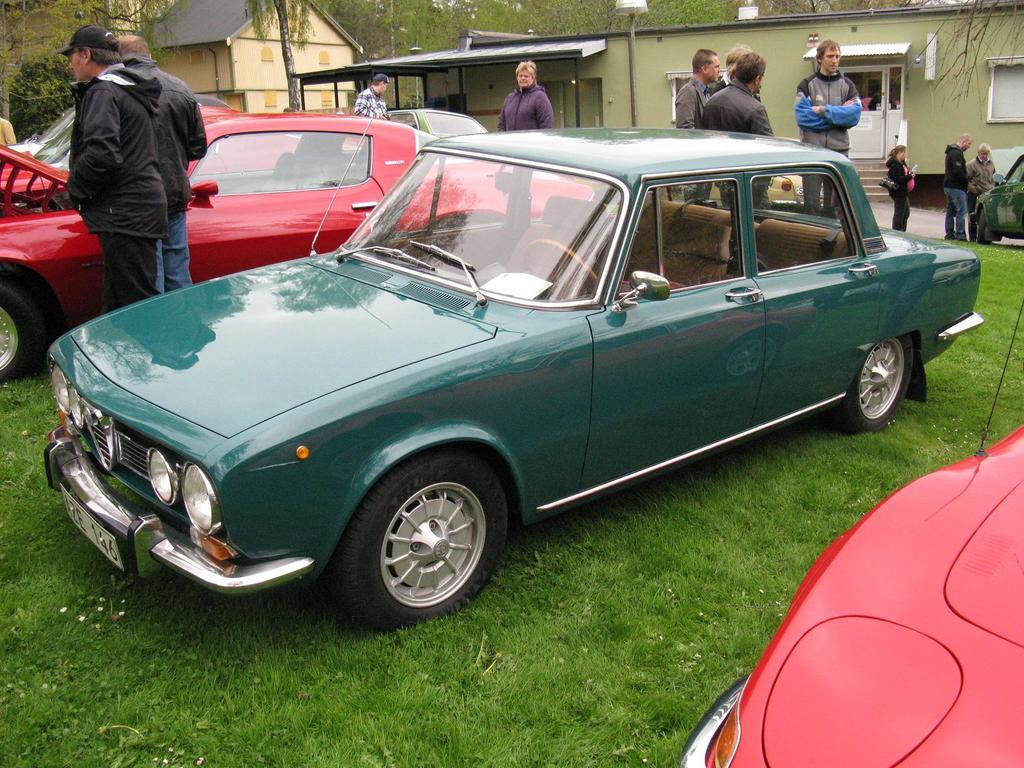What types of objects are present in the image? There are vehicles and people in the image. Where are the vehicles and people located? They are on the grass in the image. What can be seen in the background of the image? There are houses and trees in the background of the image. How many frogs are sitting on the throne in the image? There are no frogs or thrones present in the image. 